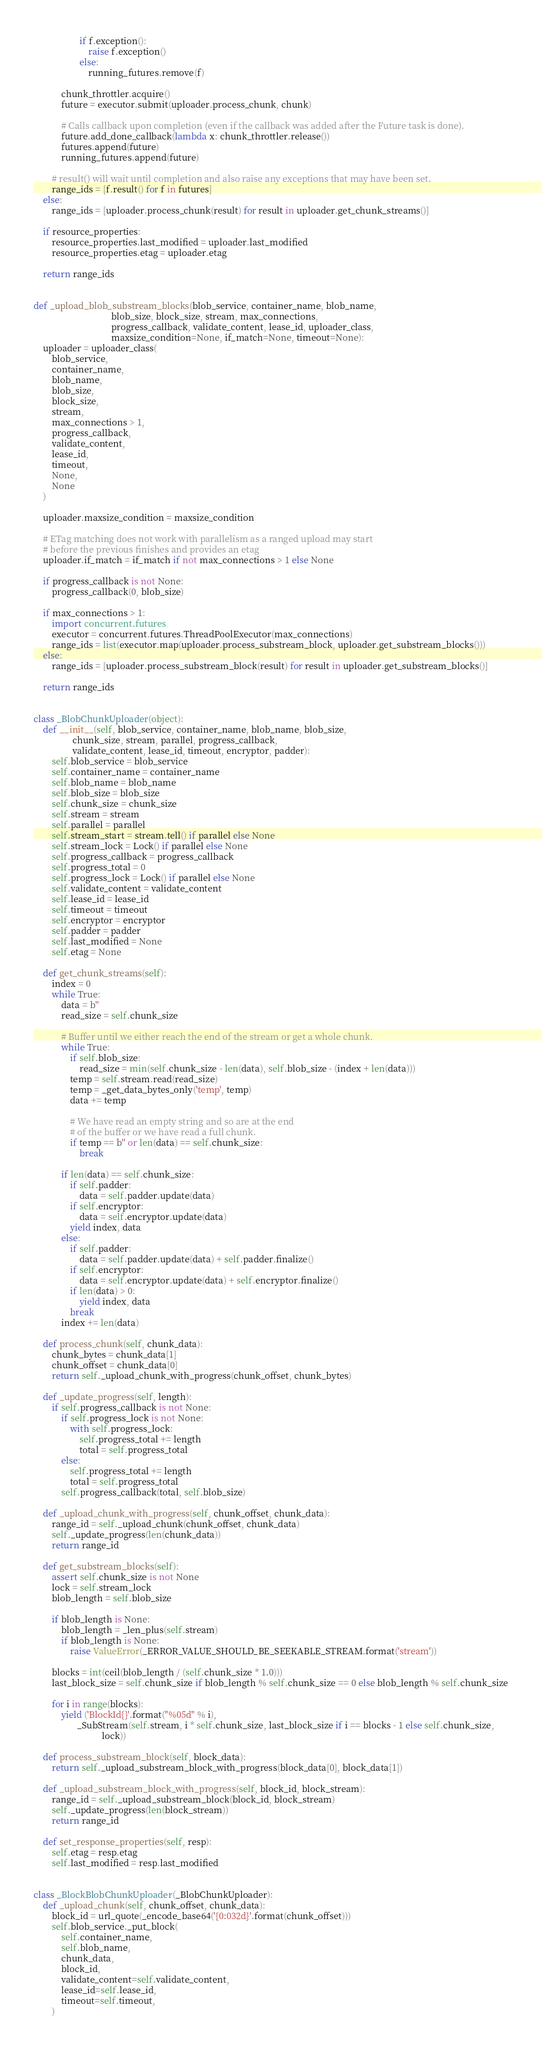<code> <loc_0><loc_0><loc_500><loc_500><_Python_>                    if f.exception():
                        raise f.exception()
                    else:
                        running_futures.remove(f)

            chunk_throttler.acquire()
            future = executor.submit(uploader.process_chunk, chunk)

            # Calls callback upon completion (even if the callback was added after the Future task is done).
            future.add_done_callback(lambda x: chunk_throttler.release())
            futures.append(future)
            running_futures.append(future)

        # result() will wait until completion and also raise any exceptions that may have been set.
        range_ids = [f.result() for f in futures]
    else:
        range_ids = [uploader.process_chunk(result) for result in uploader.get_chunk_streams()]

    if resource_properties:
        resource_properties.last_modified = uploader.last_modified
        resource_properties.etag = uploader.etag

    return range_ids


def _upload_blob_substream_blocks(blob_service, container_name, blob_name,
                                  blob_size, block_size, stream, max_connections,
                                  progress_callback, validate_content, lease_id, uploader_class,
                                  maxsize_condition=None, if_match=None, timeout=None):
    uploader = uploader_class(
        blob_service,
        container_name,
        blob_name,
        blob_size,
        block_size,
        stream,
        max_connections > 1,
        progress_callback,
        validate_content,
        lease_id,
        timeout,
        None,
        None
    )

    uploader.maxsize_condition = maxsize_condition

    # ETag matching does not work with parallelism as a ranged upload may start
    # before the previous finishes and provides an etag
    uploader.if_match = if_match if not max_connections > 1 else None

    if progress_callback is not None:
        progress_callback(0, blob_size)

    if max_connections > 1:
        import concurrent.futures
        executor = concurrent.futures.ThreadPoolExecutor(max_connections)
        range_ids = list(executor.map(uploader.process_substream_block, uploader.get_substream_blocks()))
    else:
        range_ids = [uploader.process_substream_block(result) for result in uploader.get_substream_blocks()]

    return range_ids


class _BlobChunkUploader(object):
    def __init__(self, blob_service, container_name, blob_name, blob_size,
                 chunk_size, stream, parallel, progress_callback,
                 validate_content, lease_id, timeout, encryptor, padder):
        self.blob_service = blob_service
        self.container_name = container_name
        self.blob_name = blob_name
        self.blob_size = blob_size
        self.chunk_size = chunk_size
        self.stream = stream
        self.parallel = parallel
        self.stream_start = stream.tell() if parallel else None
        self.stream_lock = Lock() if parallel else None
        self.progress_callback = progress_callback
        self.progress_total = 0
        self.progress_lock = Lock() if parallel else None
        self.validate_content = validate_content
        self.lease_id = lease_id
        self.timeout = timeout
        self.encryptor = encryptor
        self.padder = padder
        self.last_modified = None
        self.etag = None

    def get_chunk_streams(self):
        index = 0
        while True:
            data = b''
            read_size = self.chunk_size

            # Buffer until we either reach the end of the stream or get a whole chunk.
            while True:
                if self.blob_size:
                    read_size = min(self.chunk_size - len(data), self.blob_size - (index + len(data)))
                temp = self.stream.read(read_size)
                temp = _get_data_bytes_only('temp', temp)
                data += temp

                # We have read an empty string and so are at the end
                # of the buffer or we have read a full chunk.
                if temp == b'' or len(data) == self.chunk_size:
                    break

            if len(data) == self.chunk_size:
                if self.padder:
                    data = self.padder.update(data)
                if self.encryptor:
                    data = self.encryptor.update(data)
                yield index, data
            else:
                if self.padder:
                    data = self.padder.update(data) + self.padder.finalize()
                if self.encryptor:
                    data = self.encryptor.update(data) + self.encryptor.finalize()
                if len(data) > 0:
                    yield index, data
                break
            index += len(data)

    def process_chunk(self, chunk_data):
        chunk_bytes = chunk_data[1]
        chunk_offset = chunk_data[0]
        return self._upload_chunk_with_progress(chunk_offset, chunk_bytes)

    def _update_progress(self, length):
        if self.progress_callback is not None:
            if self.progress_lock is not None:
                with self.progress_lock:
                    self.progress_total += length
                    total = self.progress_total
            else:
                self.progress_total += length
                total = self.progress_total
            self.progress_callback(total, self.blob_size)

    def _upload_chunk_with_progress(self, chunk_offset, chunk_data):
        range_id = self._upload_chunk(chunk_offset, chunk_data)
        self._update_progress(len(chunk_data))
        return range_id

    def get_substream_blocks(self):
        assert self.chunk_size is not None
        lock = self.stream_lock
        blob_length = self.blob_size

        if blob_length is None:
            blob_length = _len_plus(self.stream)
            if blob_length is None:
                raise ValueError(_ERROR_VALUE_SHOULD_BE_SEEKABLE_STREAM.format('stream'))

        blocks = int(ceil(blob_length / (self.chunk_size * 1.0)))
        last_block_size = self.chunk_size if blob_length % self.chunk_size == 0 else blob_length % self.chunk_size

        for i in range(blocks):
            yield ('BlockId{}'.format("%05d" % i),
                   _SubStream(self.stream, i * self.chunk_size, last_block_size if i == blocks - 1 else self.chunk_size,
                              lock))

    def process_substream_block(self, block_data):
        return self._upload_substream_block_with_progress(block_data[0], block_data[1])

    def _upload_substream_block_with_progress(self, block_id, block_stream):
        range_id = self._upload_substream_block(block_id, block_stream)
        self._update_progress(len(block_stream))
        return range_id

    def set_response_properties(self, resp):
        self.etag = resp.etag
        self.last_modified = resp.last_modified


class _BlockBlobChunkUploader(_BlobChunkUploader):
    def _upload_chunk(self, chunk_offset, chunk_data):
        block_id = url_quote(_encode_base64('{0:032d}'.format(chunk_offset)))
        self.blob_service._put_block(
            self.container_name,
            self.blob_name,
            chunk_data,
            block_id,
            validate_content=self.validate_content,
            lease_id=self.lease_id,
            timeout=self.timeout,
        )</code> 